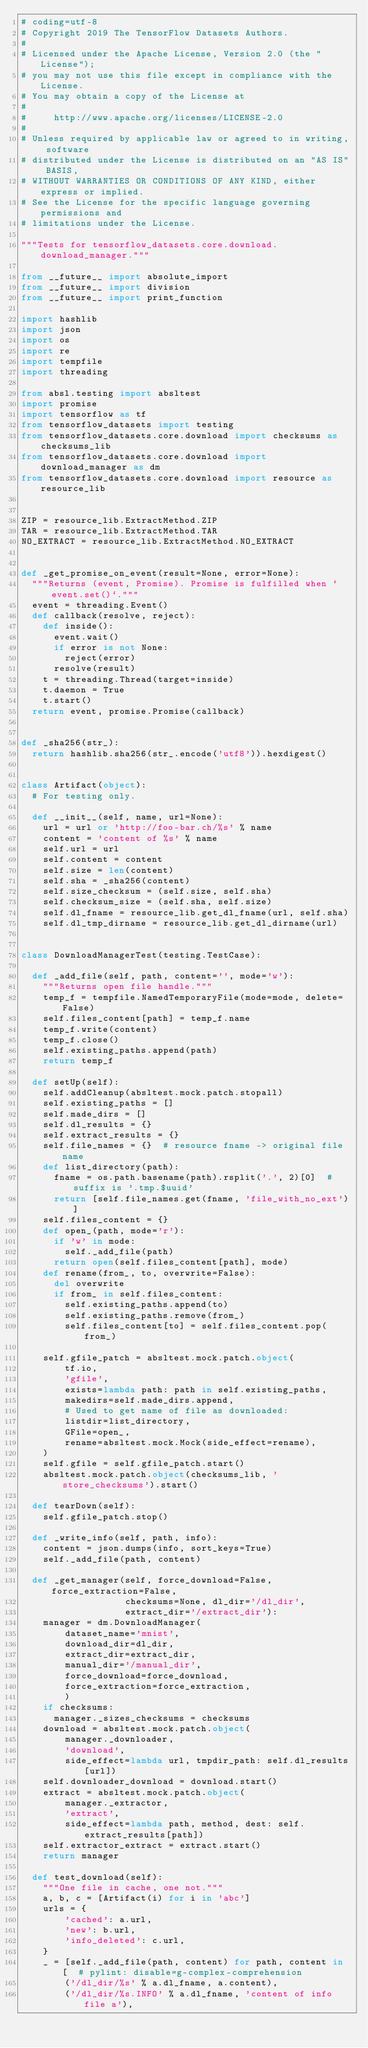<code> <loc_0><loc_0><loc_500><loc_500><_Python_># coding=utf-8
# Copyright 2019 The TensorFlow Datasets Authors.
#
# Licensed under the Apache License, Version 2.0 (the "License");
# you may not use this file except in compliance with the License.
# You may obtain a copy of the License at
#
#     http://www.apache.org/licenses/LICENSE-2.0
#
# Unless required by applicable law or agreed to in writing, software
# distributed under the License is distributed on an "AS IS" BASIS,
# WITHOUT WARRANTIES OR CONDITIONS OF ANY KIND, either express or implied.
# See the License for the specific language governing permissions and
# limitations under the License.

"""Tests for tensorflow_datasets.core.download.download_manager."""

from __future__ import absolute_import
from __future__ import division
from __future__ import print_function

import hashlib
import json
import os
import re
import tempfile
import threading

from absl.testing import absltest
import promise
import tensorflow as tf
from tensorflow_datasets import testing
from tensorflow_datasets.core.download import checksums as checksums_lib
from tensorflow_datasets.core.download import download_manager as dm
from tensorflow_datasets.core.download import resource as resource_lib


ZIP = resource_lib.ExtractMethod.ZIP
TAR = resource_lib.ExtractMethod.TAR
NO_EXTRACT = resource_lib.ExtractMethod.NO_EXTRACT


def _get_promise_on_event(result=None, error=None):
  """Returns (event, Promise). Promise is fulfilled when `event.set()`."""
  event = threading.Event()
  def callback(resolve, reject):
    def inside():
      event.wait()
      if error is not None:
        reject(error)
      resolve(result)
    t = threading.Thread(target=inside)
    t.daemon = True
    t.start()
  return event, promise.Promise(callback)


def _sha256(str_):
  return hashlib.sha256(str_.encode('utf8')).hexdigest()


class Artifact(object):
  # For testing only.

  def __init__(self, name, url=None):
    url = url or 'http://foo-bar.ch/%s' % name
    content = 'content of %s' % name
    self.url = url
    self.content = content
    self.size = len(content)
    self.sha = _sha256(content)
    self.size_checksum = (self.size, self.sha)
    self.checksum_size = (self.sha, self.size)
    self.dl_fname = resource_lib.get_dl_fname(url, self.sha)
    self.dl_tmp_dirname = resource_lib.get_dl_dirname(url)


class DownloadManagerTest(testing.TestCase):

  def _add_file(self, path, content='', mode='w'):
    """Returns open file handle."""
    temp_f = tempfile.NamedTemporaryFile(mode=mode, delete=False)
    self.files_content[path] = temp_f.name
    temp_f.write(content)
    temp_f.close()
    self.existing_paths.append(path)
    return temp_f

  def setUp(self):
    self.addCleanup(absltest.mock.patch.stopall)
    self.existing_paths = []
    self.made_dirs = []
    self.dl_results = {}
    self.extract_results = {}
    self.file_names = {}  # resource fname -> original file name
    def list_directory(path):
      fname = os.path.basename(path).rsplit('.', 2)[0]  # suffix is '.tmp.$uuid'
      return [self.file_names.get(fname, 'file_with_no_ext')]
    self.files_content = {}
    def open_(path, mode='r'):
      if 'w' in mode:
        self._add_file(path)
      return open(self.files_content[path], mode)
    def rename(from_, to, overwrite=False):
      del overwrite
      if from_ in self.files_content:
        self.existing_paths.append(to)
        self.existing_paths.remove(from_)
        self.files_content[to] = self.files_content.pop(from_)

    self.gfile_patch = absltest.mock.patch.object(
        tf.io,
        'gfile',
        exists=lambda path: path in self.existing_paths,
        makedirs=self.made_dirs.append,
        # Used to get name of file as downloaded:
        listdir=list_directory,
        GFile=open_,
        rename=absltest.mock.Mock(side_effect=rename),
    )
    self.gfile = self.gfile_patch.start()
    absltest.mock.patch.object(checksums_lib, 'store_checksums').start()

  def tearDown(self):
    self.gfile_patch.stop()

  def _write_info(self, path, info):
    content = json.dumps(info, sort_keys=True)
    self._add_file(path, content)

  def _get_manager(self, force_download=False, force_extraction=False,
                   checksums=None, dl_dir='/dl_dir',
                   extract_dir='/extract_dir'):
    manager = dm.DownloadManager(
        dataset_name='mnist',
        download_dir=dl_dir,
        extract_dir=extract_dir,
        manual_dir='/manual_dir',
        force_download=force_download,
        force_extraction=force_extraction,
        )
    if checksums:
      manager._sizes_checksums = checksums
    download = absltest.mock.patch.object(
        manager._downloader,
        'download',
        side_effect=lambda url, tmpdir_path: self.dl_results[url])
    self.downloader_download = download.start()
    extract = absltest.mock.patch.object(
        manager._extractor,
        'extract',
        side_effect=lambda path, method, dest: self.extract_results[path])
    self.extractor_extract = extract.start()
    return manager

  def test_download(self):
    """One file in cache, one not."""
    a, b, c = [Artifact(i) for i in 'abc']
    urls = {
        'cached': a.url,
        'new': b.url,
        'info_deleted': c.url,
    }
    _ = [self._add_file(path, content) for path, content in [  # pylint: disable=g-complex-comprehension
        ('/dl_dir/%s' % a.dl_fname, a.content),
        ('/dl_dir/%s.INFO' % a.dl_fname, 'content of info file a'),</code> 